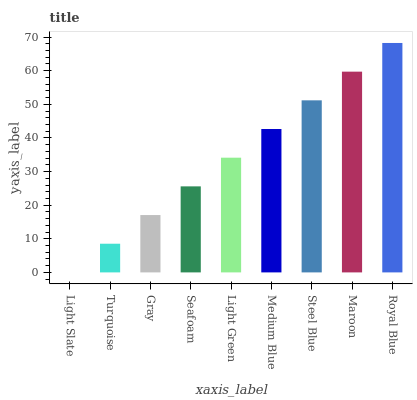Is Turquoise the minimum?
Answer yes or no. No. Is Turquoise the maximum?
Answer yes or no. No. Is Turquoise greater than Light Slate?
Answer yes or no. Yes. Is Light Slate less than Turquoise?
Answer yes or no. Yes. Is Light Slate greater than Turquoise?
Answer yes or no. No. Is Turquoise less than Light Slate?
Answer yes or no. No. Is Light Green the high median?
Answer yes or no. Yes. Is Light Green the low median?
Answer yes or no. Yes. Is Light Slate the high median?
Answer yes or no. No. Is Maroon the low median?
Answer yes or no. No. 